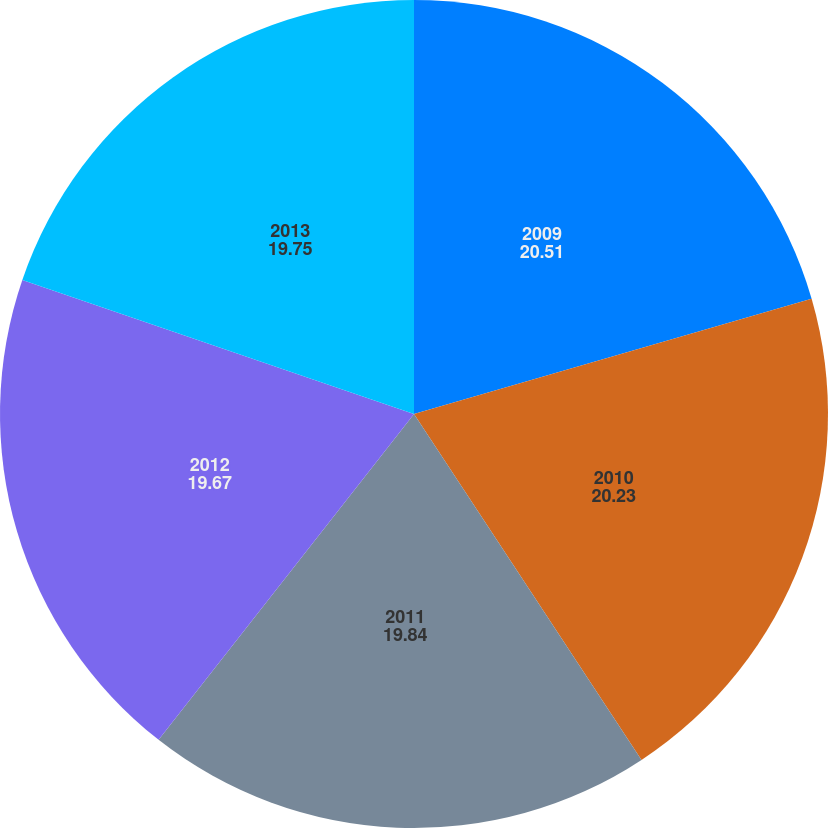<chart> <loc_0><loc_0><loc_500><loc_500><pie_chart><fcel>2009<fcel>2010<fcel>2011<fcel>2012<fcel>2013<nl><fcel>20.51%<fcel>20.23%<fcel>19.84%<fcel>19.67%<fcel>19.75%<nl></chart> 